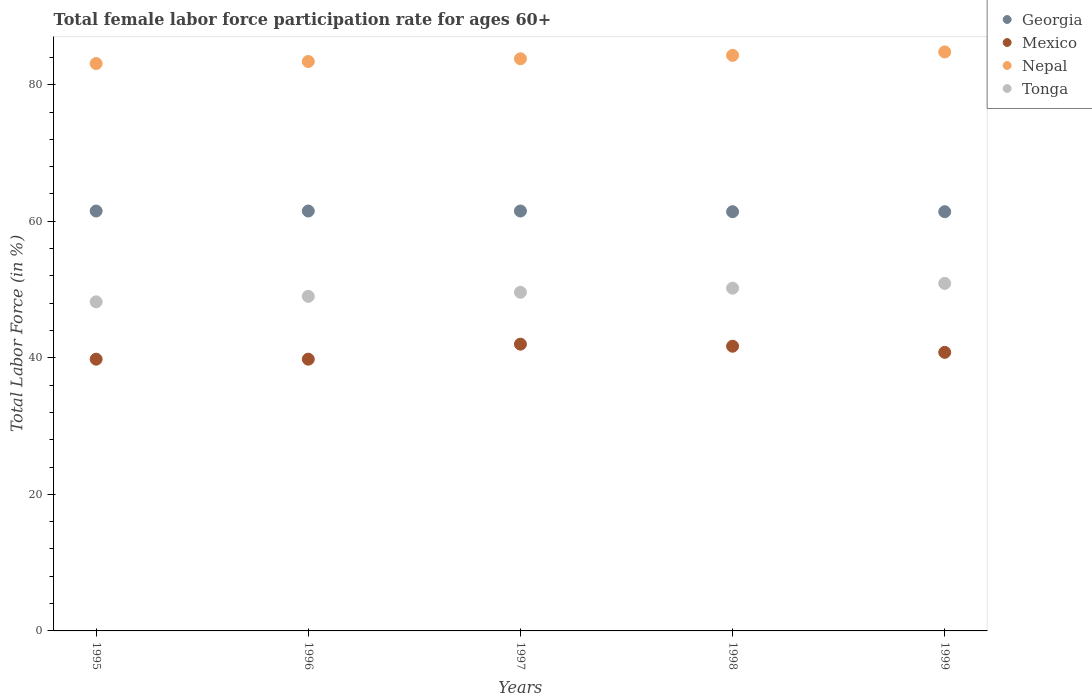Is the number of dotlines equal to the number of legend labels?
Offer a very short reply. Yes. What is the female labor force participation rate in Tonga in 1995?
Provide a short and direct response. 48.2. Across all years, what is the maximum female labor force participation rate in Tonga?
Offer a very short reply. 50.9. Across all years, what is the minimum female labor force participation rate in Nepal?
Provide a succinct answer. 83.1. In which year was the female labor force participation rate in Tonga maximum?
Make the answer very short. 1999. In which year was the female labor force participation rate in Mexico minimum?
Ensure brevity in your answer.  1995. What is the total female labor force participation rate in Nepal in the graph?
Offer a terse response. 419.4. What is the difference between the female labor force participation rate in Georgia in 1998 and the female labor force participation rate in Mexico in 1996?
Your response must be concise. 21.6. What is the average female labor force participation rate in Georgia per year?
Make the answer very short. 61.46. In the year 1996, what is the difference between the female labor force participation rate in Georgia and female labor force participation rate in Tonga?
Ensure brevity in your answer.  12.5. What is the ratio of the female labor force participation rate in Georgia in 1997 to that in 1998?
Keep it short and to the point. 1. Is the difference between the female labor force participation rate in Georgia in 1995 and 1996 greater than the difference between the female labor force participation rate in Tonga in 1995 and 1996?
Provide a short and direct response. Yes. What is the difference between the highest and the second highest female labor force participation rate in Mexico?
Your answer should be compact. 0.3. What is the difference between the highest and the lowest female labor force participation rate in Mexico?
Offer a terse response. 2.2. Is the female labor force participation rate in Nepal strictly less than the female labor force participation rate in Georgia over the years?
Provide a short and direct response. No. What is the difference between two consecutive major ticks on the Y-axis?
Offer a very short reply. 20. Are the values on the major ticks of Y-axis written in scientific E-notation?
Provide a short and direct response. No. Does the graph contain any zero values?
Ensure brevity in your answer.  No. How many legend labels are there?
Ensure brevity in your answer.  4. What is the title of the graph?
Provide a short and direct response. Total female labor force participation rate for ages 60+. Does "Monaco" appear as one of the legend labels in the graph?
Give a very brief answer. No. What is the label or title of the X-axis?
Give a very brief answer. Years. What is the label or title of the Y-axis?
Give a very brief answer. Total Labor Force (in %). What is the Total Labor Force (in %) of Georgia in 1995?
Make the answer very short. 61.5. What is the Total Labor Force (in %) in Mexico in 1995?
Your answer should be very brief. 39.8. What is the Total Labor Force (in %) in Nepal in 1995?
Provide a short and direct response. 83.1. What is the Total Labor Force (in %) of Tonga in 1995?
Provide a short and direct response. 48.2. What is the Total Labor Force (in %) of Georgia in 1996?
Offer a very short reply. 61.5. What is the Total Labor Force (in %) in Mexico in 1996?
Provide a succinct answer. 39.8. What is the Total Labor Force (in %) of Nepal in 1996?
Your answer should be compact. 83.4. What is the Total Labor Force (in %) of Georgia in 1997?
Your response must be concise. 61.5. What is the Total Labor Force (in %) in Nepal in 1997?
Ensure brevity in your answer.  83.8. What is the Total Labor Force (in %) of Tonga in 1997?
Provide a short and direct response. 49.6. What is the Total Labor Force (in %) in Georgia in 1998?
Give a very brief answer. 61.4. What is the Total Labor Force (in %) in Mexico in 1998?
Make the answer very short. 41.7. What is the Total Labor Force (in %) of Nepal in 1998?
Offer a terse response. 84.3. What is the Total Labor Force (in %) of Tonga in 1998?
Your response must be concise. 50.2. What is the Total Labor Force (in %) of Georgia in 1999?
Provide a succinct answer. 61.4. What is the Total Labor Force (in %) in Mexico in 1999?
Give a very brief answer. 40.8. What is the Total Labor Force (in %) of Nepal in 1999?
Provide a succinct answer. 84.8. What is the Total Labor Force (in %) in Tonga in 1999?
Your answer should be very brief. 50.9. Across all years, what is the maximum Total Labor Force (in %) of Georgia?
Provide a succinct answer. 61.5. Across all years, what is the maximum Total Labor Force (in %) in Nepal?
Ensure brevity in your answer.  84.8. Across all years, what is the maximum Total Labor Force (in %) in Tonga?
Provide a short and direct response. 50.9. Across all years, what is the minimum Total Labor Force (in %) in Georgia?
Your response must be concise. 61.4. Across all years, what is the minimum Total Labor Force (in %) of Mexico?
Ensure brevity in your answer.  39.8. Across all years, what is the minimum Total Labor Force (in %) of Nepal?
Ensure brevity in your answer.  83.1. Across all years, what is the minimum Total Labor Force (in %) of Tonga?
Make the answer very short. 48.2. What is the total Total Labor Force (in %) of Georgia in the graph?
Your response must be concise. 307.3. What is the total Total Labor Force (in %) in Mexico in the graph?
Give a very brief answer. 204.1. What is the total Total Labor Force (in %) in Nepal in the graph?
Offer a terse response. 419.4. What is the total Total Labor Force (in %) in Tonga in the graph?
Give a very brief answer. 247.9. What is the difference between the Total Labor Force (in %) in Georgia in 1995 and that in 1996?
Offer a terse response. 0. What is the difference between the Total Labor Force (in %) in Nepal in 1995 and that in 1996?
Make the answer very short. -0.3. What is the difference between the Total Labor Force (in %) in Tonga in 1995 and that in 1996?
Offer a terse response. -0.8. What is the difference between the Total Labor Force (in %) of Mexico in 1995 and that in 1997?
Your response must be concise. -2.2. What is the difference between the Total Labor Force (in %) in Nepal in 1995 and that in 1997?
Keep it short and to the point. -0.7. What is the difference between the Total Labor Force (in %) of Georgia in 1995 and that in 1998?
Give a very brief answer. 0.1. What is the difference between the Total Labor Force (in %) of Mexico in 1995 and that in 1999?
Give a very brief answer. -1. What is the difference between the Total Labor Force (in %) in Tonga in 1995 and that in 1999?
Provide a succinct answer. -2.7. What is the difference between the Total Labor Force (in %) in Georgia in 1996 and that in 1997?
Your answer should be compact. 0. What is the difference between the Total Labor Force (in %) of Mexico in 1996 and that in 1998?
Your answer should be compact. -1.9. What is the difference between the Total Labor Force (in %) in Georgia in 1996 and that in 1999?
Make the answer very short. 0.1. What is the difference between the Total Labor Force (in %) in Tonga in 1996 and that in 1999?
Your answer should be compact. -1.9. What is the difference between the Total Labor Force (in %) of Georgia in 1997 and that in 1998?
Give a very brief answer. 0.1. What is the difference between the Total Labor Force (in %) in Mexico in 1997 and that in 1998?
Make the answer very short. 0.3. What is the difference between the Total Labor Force (in %) of Nepal in 1997 and that in 1998?
Ensure brevity in your answer.  -0.5. What is the difference between the Total Labor Force (in %) of Mexico in 1997 and that in 1999?
Your answer should be very brief. 1.2. What is the difference between the Total Labor Force (in %) of Tonga in 1997 and that in 1999?
Your answer should be compact. -1.3. What is the difference between the Total Labor Force (in %) in Georgia in 1998 and that in 1999?
Keep it short and to the point. 0. What is the difference between the Total Labor Force (in %) in Tonga in 1998 and that in 1999?
Your answer should be very brief. -0.7. What is the difference between the Total Labor Force (in %) in Georgia in 1995 and the Total Labor Force (in %) in Mexico in 1996?
Provide a short and direct response. 21.7. What is the difference between the Total Labor Force (in %) of Georgia in 1995 and the Total Labor Force (in %) of Nepal in 1996?
Make the answer very short. -21.9. What is the difference between the Total Labor Force (in %) of Georgia in 1995 and the Total Labor Force (in %) of Tonga in 1996?
Keep it short and to the point. 12.5. What is the difference between the Total Labor Force (in %) in Mexico in 1995 and the Total Labor Force (in %) in Nepal in 1996?
Offer a terse response. -43.6. What is the difference between the Total Labor Force (in %) in Mexico in 1995 and the Total Labor Force (in %) in Tonga in 1996?
Your answer should be compact. -9.2. What is the difference between the Total Labor Force (in %) in Nepal in 1995 and the Total Labor Force (in %) in Tonga in 1996?
Provide a short and direct response. 34.1. What is the difference between the Total Labor Force (in %) of Georgia in 1995 and the Total Labor Force (in %) of Mexico in 1997?
Give a very brief answer. 19.5. What is the difference between the Total Labor Force (in %) in Georgia in 1995 and the Total Labor Force (in %) in Nepal in 1997?
Provide a short and direct response. -22.3. What is the difference between the Total Labor Force (in %) in Mexico in 1995 and the Total Labor Force (in %) in Nepal in 1997?
Your answer should be compact. -44. What is the difference between the Total Labor Force (in %) in Mexico in 1995 and the Total Labor Force (in %) in Tonga in 1997?
Offer a terse response. -9.8. What is the difference between the Total Labor Force (in %) in Nepal in 1995 and the Total Labor Force (in %) in Tonga in 1997?
Provide a short and direct response. 33.5. What is the difference between the Total Labor Force (in %) in Georgia in 1995 and the Total Labor Force (in %) in Mexico in 1998?
Your answer should be compact. 19.8. What is the difference between the Total Labor Force (in %) in Georgia in 1995 and the Total Labor Force (in %) in Nepal in 1998?
Keep it short and to the point. -22.8. What is the difference between the Total Labor Force (in %) in Mexico in 1995 and the Total Labor Force (in %) in Nepal in 1998?
Provide a succinct answer. -44.5. What is the difference between the Total Labor Force (in %) of Mexico in 1995 and the Total Labor Force (in %) of Tonga in 1998?
Keep it short and to the point. -10.4. What is the difference between the Total Labor Force (in %) in Nepal in 1995 and the Total Labor Force (in %) in Tonga in 1998?
Your response must be concise. 32.9. What is the difference between the Total Labor Force (in %) in Georgia in 1995 and the Total Labor Force (in %) in Mexico in 1999?
Provide a succinct answer. 20.7. What is the difference between the Total Labor Force (in %) of Georgia in 1995 and the Total Labor Force (in %) of Nepal in 1999?
Your response must be concise. -23.3. What is the difference between the Total Labor Force (in %) of Georgia in 1995 and the Total Labor Force (in %) of Tonga in 1999?
Ensure brevity in your answer.  10.6. What is the difference between the Total Labor Force (in %) of Mexico in 1995 and the Total Labor Force (in %) of Nepal in 1999?
Your answer should be compact. -45. What is the difference between the Total Labor Force (in %) in Nepal in 1995 and the Total Labor Force (in %) in Tonga in 1999?
Provide a succinct answer. 32.2. What is the difference between the Total Labor Force (in %) of Georgia in 1996 and the Total Labor Force (in %) of Mexico in 1997?
Ensure brevity in your answer.  19.5. What is the difference between the Total Labor Force (in %) in Georgia in 1996 and the Total Labor Force (in %) in Nepal in 1997?
Offer a terse response. -22.3. What is the difference between the Total Labor Force (in %) in Georgia in 1996 and the Total Labor Force (in %) in Tonga in 1997?
Offer a terse response. 11.9. What is the difference between the Total Labor Force (in %) of Mexico in 1996 and the Total Labor Force (in %) of Nepal in 1997?
Offer a very short reply. -44. What is the difference between the Total Labor Force (in %) in Nepal in 1996 and the Total Labor Force (in %) in Tonga in 1997?
Offer a very short reply. 33.8. What is the difference between the Total Labor Force (in %) in Georgia in 1996 and the Total Labor Force (in %) in Mexico in 1998?
Your answer should be very brief. 19.8. What is the difference between the Total Labor Force (in %) in Georgia in 1996 and the Total Labor Force (in %) in Nepal in 1998?
Keep it short and to the point. -22.8. What is the difference between the Total Labor Force (in %) of Mexico in 1996 and the Total Labor Force (in %) of Nepal in 1998?
Provide a short and direct response. -44.5. What is the difference between the Total Labor Force (in %) in Nepal in 1996 and the Total Labor Force (in %) in Tonga in 1998?
Keep it short and to the point. 33.2. What is the difference between the Total Labor Force (in %) of Georgia in 1996 and the Total Labor Force (in %) of Mexico in 1999?
Offer a very short reply. 20.7. What is the difference between the Total Labor Force (in %) of Georgia in 1996 and the Total Labor Force (in %) of Nepal in 1999?
Offer a very short reply. -23.3. What is the difference between the Total Labor Force (in %) of Mexico in 1996 and the Total Labor Force (in %) of Nepal in 1999?
Make the answer very short. -45. What is the difference between the Total Labor Force (in %) in Nepal in 1996 and the Total Labor Force (in %) in Tonga in 1999?
Give a very brief answer. 32.5. What is the difference between the Total Labor Force (in %) in Georgia in 1997 and the Total Labor Force (in %) in Mexico in 1998?
Offer a very short reply. 19.8. What is the difference between the Total Labor Force (in %) in Georgia in 1997 and the Total Labor Force (in %) in Nepal in 1998?
Your answer should be compact. -22.8. What is the difference between the Total Labor Force (in %) of Georgia in 1997 and the Total Labor Force (in %) of Tonga in 1998?
Give a very brief answer. 11.3. What is the difference between the Total Labor Force (in %) of Mexico in 1997 and the Total Labor Force (in %) of Nepal in 1998?
Your answer should be very brief. -42.3. What is the difference between the Total Labor Force (in %) of Nepal in 1997 and the Total Labor Force (in %) of Tonga in 1998?
Your response must be concise. 33.6. What is the difference between the Total Labor Force (in %) in Georgia in 1997 and the Total Labor Force (in %) in Mexico in 1999?
Your answer should be very brief. 20.7. What is the difference between the Total Labor Force (in %) of Georgia in 1997 and the Total Labor Force (in %) of Nepal in 1999?
Ensure brevity in your answer.  -23.3. What is the difference between the Total Labor Force (in %) of Mexico in 1997 and the Total Labor Force (in %) of Nepal in 1999?
Your answer should be very brief. -42.8. What is the difference between the Total Labor Force (in %) of Nepal in 1997 and the Total Labor Force (in %) of Tonga in 1999?
Your answer should be very brief. 32.9. What is the difference between the Total Labor Force (in %) of Georgia in 1998 and the Total Labor Force (in %) of Mexico in 1999?
Provide a succinct answer. 20.6. What is the difference between the Total Labor Force (in %) in Georgia in 1998 and the Total Labor Force (in %) in Nepal in 1999?
Your answer should be compact. -23.4. What is the difference between the Total Labor Force (in %) of Mexico in 1998 and the Total Labor Force (in %) of Nepal in 1999?
Your answer should be very brief. -43.1. What is the difference between the Total Labor Force (in %) in Mexico in 1998 and the Total Labor Force (in %) in Tonga in 1999?
Your answer should be compact. -9.2. What is the difference between the Total Labor Force (in %) in Nepal in 1998 and the Total Labor Force (in %) in Tonga in 1999?
Offer a terse response. 33.4. What is the average Total Labor Force (in %) in Georgia per year?
Your response must be concise. 61.46. What is the average Total Labor Force (in %) of Mexico per year?
Offer a very short reply. 40.82. What is the average Total Labor Force (in %) in Nepal per year?
Offer a very short reply. 83.88. What is the average Total Labor Force (in %) in Tonga per year?
Give a very brief answer. 49.58. In the year 1995, what is the difference between the Total Labor Force (in %) in Georgia and Total Labor Force (in %) in Mexico?
Keep it short and to the point. 21.7. In the year 1995, what is the difference between the Total Labor Force (in %) in Georgia and Total Labor Force (in %) in Nepal?
Your response must be concise. -21.6. In the year 1995, what is the difference between the Total Labor Force (in %) of Mexico and Total Labor Force (in %) of Nepal?
Give a very brief answer. -43.3. In the year 1995, what is the difference between the Total Labor Force (in %) in Nepal and Total Labor Force (in %) in Tonga?
Your response must be concise. 34.9. In the year 1996, what is the difference between the Total Labor Force (in %) of Georgia and Total Labor Force (in %) of Mexico?
Keep it short and to the point. 21.7. In the year 1996, what is the difference between the Total Labor Force (in %) in Georgia and Total Labor Force (in %) in Nepal?
Provide a short and direct response. -21.9. In the year 1996, what is the difference between the Total Labor Force (in %) of Georgia and Total Labor Force (in %) of Tonga?
Give a very brief answer. 12.5. In the year 1996, what is the difference between the Total Labor Force (in %) in Mexico and Total Labor Force (in %) in Nepal?
Give a very brief answer. -43.6. In the year 1996, what is the difference between the Total Labor Force (in %) in Mexico and Total Labor Force (in %) in Tonga?
Offer a terse response. -9.2. In the year 1996, what is the difference between the Total Labor Force (in %) of Nepal and Total Labor Force (in %) of Tonga?
Offer a very short reply. 34.4. In the year 1997, what is the difference between the Total Labor Force (in %) of Georgia and Total Labor Force (in %) of Nepal?
Your answer should be compact. -22.3. In the year 1997, what is the difference between the Total Labor Force (in %) of Georgia and Total Labor Force (in %) of Tonga?
Your answer should be very brief. 11.9. In the year 1997, what is the difference between the Total Labor Force (in %) in Mexico and Total Labor Force (in %) in Nepal?
Your answer should be compact. -41.8. In the year 1997, what is the difference between the Total Labor Force (in %) in Mexico and Total Labor Force (in %) in Tonga?
Your answer should be very brief. -7.6. In the year 1997, what is the difference between the Total Labor Force (in %) in Nepal and Total Labor Force (in %) in Tonga?
Give a very brief answer. 34.2. In the year 1998, what is the difference between the Total Labor Force (in %) in Georgia and Total Labor Force (in %) in Nepal?
Ensure brevity in your answer.  -22.9. In the year 1998, what is the difference between the Total Labor Force (in %) in Georgia and Total Labor Force (in %) in Tonga?
Make the answer very short. 11.2. In the year 1998, what is the difference between the Total Labor Force (in %) of Mexico and Total Labor Force (in %) of Nepal?
Give a very brief answer. -42.6. In the year 1998, what is the difference between the Total Labor Force (in %) of Nepal and Total Labor Force (in %) of Tonga?
Your response must be concise. 34.1. In the year 1999, what is the difference between the Total Labor Force (in %) in Georgia and Total Labor Force (in %) in Mexico?
Offer a terse response. 20.6. In the year 1999, what is the difference between the Total Labor Force (in %) in Georgia and Total Labor Force (in %) in Nepal?
Give a very brief answer. -23.4. In the year 1999, what is the difference between the Total Labor Force (in %) of Georgia and Total Labor Force (in %) of Tonga?
Provide a short and direct response. 10.5. In the year 1999, what is the difference between the Total Labor Force (in %) in Mexico and Total Labor Force (in %) in Nepal?
Provide a short and direct response. -44. In the year 1999, what is the difference between the Total Labor Force (in %) of Nepal and Total Labor Force (in %) of Tonga?
Give a very brief answer. 33.9. What is the ratio of the Total Labor Force (in %) in Mexico in 1995 to that in 1996?
Your answer should be compact. 1. What is the ratio of the Total Labor Force (in %) of Tonga in 1995 to that in 1996?
Your answer should be compact. 0.98. What is the ratio of the Total Labor Force (in %) of Georgia in 1995 to that in 1997?
Offer a terse response. 1. What is the ratio of the Total Labor Force (in %) of Mexico in 1995 to that in 1997?
Provide a short and direct response. 0.95. What is the ratio of the Total Labor Force (in %) in Tonga in 1995 to that in 1997?
Your answer should be compact. 0.97. What is the ratio of the Total Labor Force (in %) in Mexico in 1995 to that in 1998?
Make the answer very short. 0.95. What is the ratio of the Total Labor Force (in %) of Nepal in 1995 to that in 1998?
Offer a very short reply. 0.99. What is the ratio of the Total Labor Force (in %) of Tonga in 1995 to that in 1998?
Offer a terse response. 0.96. What is the ratio of the Total Labor Force (in %) in Georgia in 1995 to that in 1999?
Your answer should be very brief. 1. What is the ratio of the Total Labor Force (in %) of Mexico in 1995 to that in 1999?
Provide a short and direct response. 0.98. What is the ratio of the Total Labor Force (in %) in Tonga in 1995 to that in 1999?
Offer a very short reply. 0.95. What is the ratio of the Total Labor Force (in %) of Georgia in 1996 to that in 1997?
Ensure brevity in your answer.  1. What is the ratio of the Total Labor Force (in %) in Mexico in 1996 to that in 1997?
Keep it short and to the point. 0.95. What is the ratio of the Total Labor Force (in %) of Tonga in 1996 to that in 1997?
Your answer should be very brief. 0.99. What is the ratio of the Total Labor Force (in %) of Georgia in 1996 to that in 1998?
Make the answer very short. 1. What is the ratio of the Total Labor Force (in %) of Mexico in 1996 to that in 1998?
Your answer should be very brief. 0.95. What is the ratio of the Total Labor Force (in %) of Nepal in 1996 to that in 1998?
Keep it short and to the point. 0.99. What is the ratio of the Total Labor Force (in %) in Tonga in 1996 to that in 1998?
Ensure brevity in your answer.  0.98. What is the ratio of the Total Labor Force (in %) of Mexico in 1996 to that in 1999?
Provide a short and direct response. 0.98. What is the ratio of the Total Labor Force (in %) of Nepal in 1996 to that in 1999?
Provide a short and direct response. 0.98. What is the ratio of the Total Labor Force (in %) of Tonga in 1996 to that in 1999?
Your answer should be compact. 0.96. What is the ratio of the Total Labor Force (in %) in Nepal in 1997 to that in 1998?
Offer a very short reply. 0.99. What is the ratio of the Total Labor Force (in %) of Mexico in 1997 to that in 1999?
Make the answer very short. 1.03. What is the ratio of the Total Labor Force (in %) of Nepal in 1997 to that in 1999?
Provide a succinct answer. 0.99. What is the ratio of the Total Labor Force (in %) of Tonga in 1997 to that in 1999?
Ensure brevity in your answer.  0.97. What is the ratio of the Total Labor Force (in %) in Mexico in 1998 to that in 1999?
Provide a succinct answer. 1.02. What is the ratio of the Total Labor Force (in %) in Tonga in 1998 to that in 1999?
Give a very brief answer. 0.99. What is the difference between the highest and the second highest Total Labor Force (in %) of Tonga?
Make the answer very short. 0.7. What is the difference between the highest and the lowest Total Labor Force (in %) of Mexico?
Ensure brevity in your answer.  2.2. What is the difference between the highest and the lowest Total Labor Force (in %) in Nepal?
Offer a terse response. 1.7. 